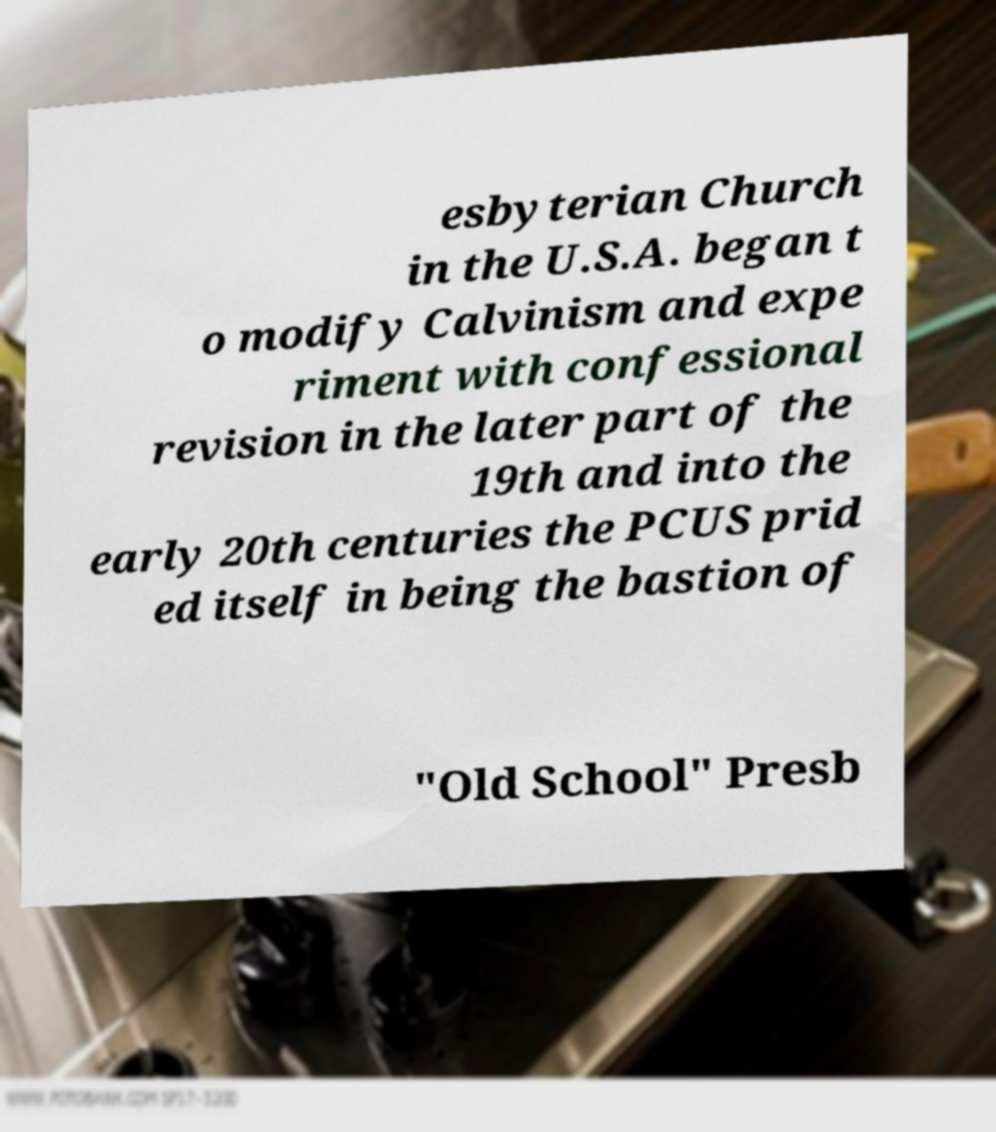Can you read and provide the text displayed in the image?This photo seems to have some interesting text. Can you extract and type it out for me? esbyterian Church in the U.S.A. began t o modify Calvinism and expe riment with confessional revision in the later part of the 19th and into the early 20th centuries the PCUS prid ed itself in being the bastion of "Old School" Presb 